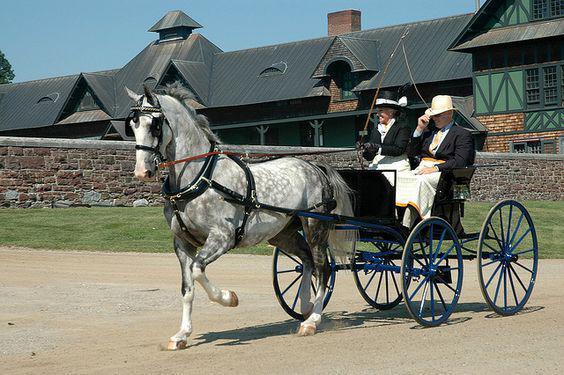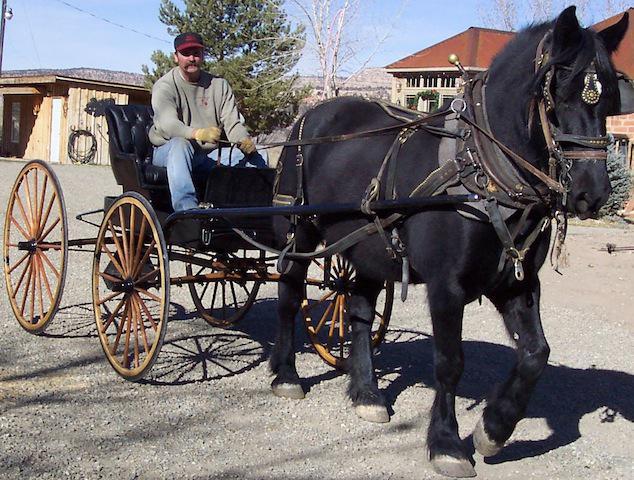The first image is the image on the left, the second image is the image on the right. Examine the images to the left and right. Is the description "There is one rider in the cart on the left" accurate? Answer yes or no. No. The first image is the image on the left, the second image is the image on the right. For the images displayed, is the sentence "Right image includes a wagon pulled by at least one tan Clydesdale horse" factually correct? Answer yes or no. No. 